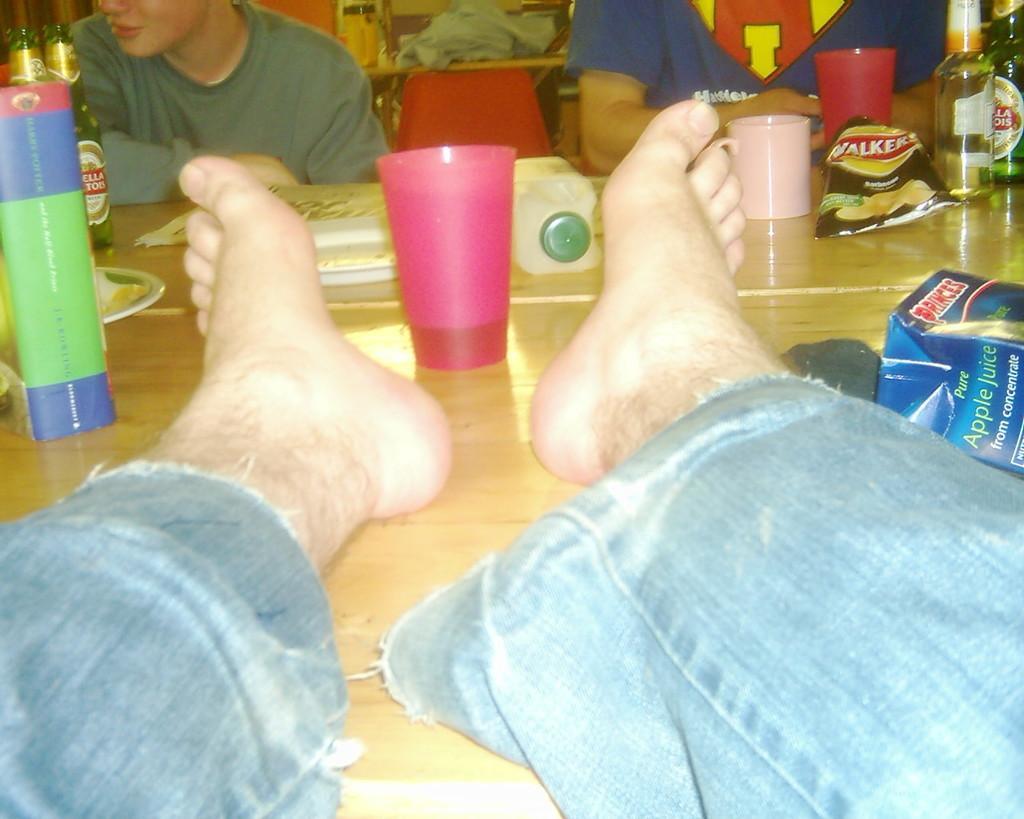Please provide a concise description of this image. In the center of the image, we can see person's legs on the table and there are bottles, cups, glasses, plates are also there on the table. In the background, we can see people sitting on the chairs and we can see an object which is in red color. 